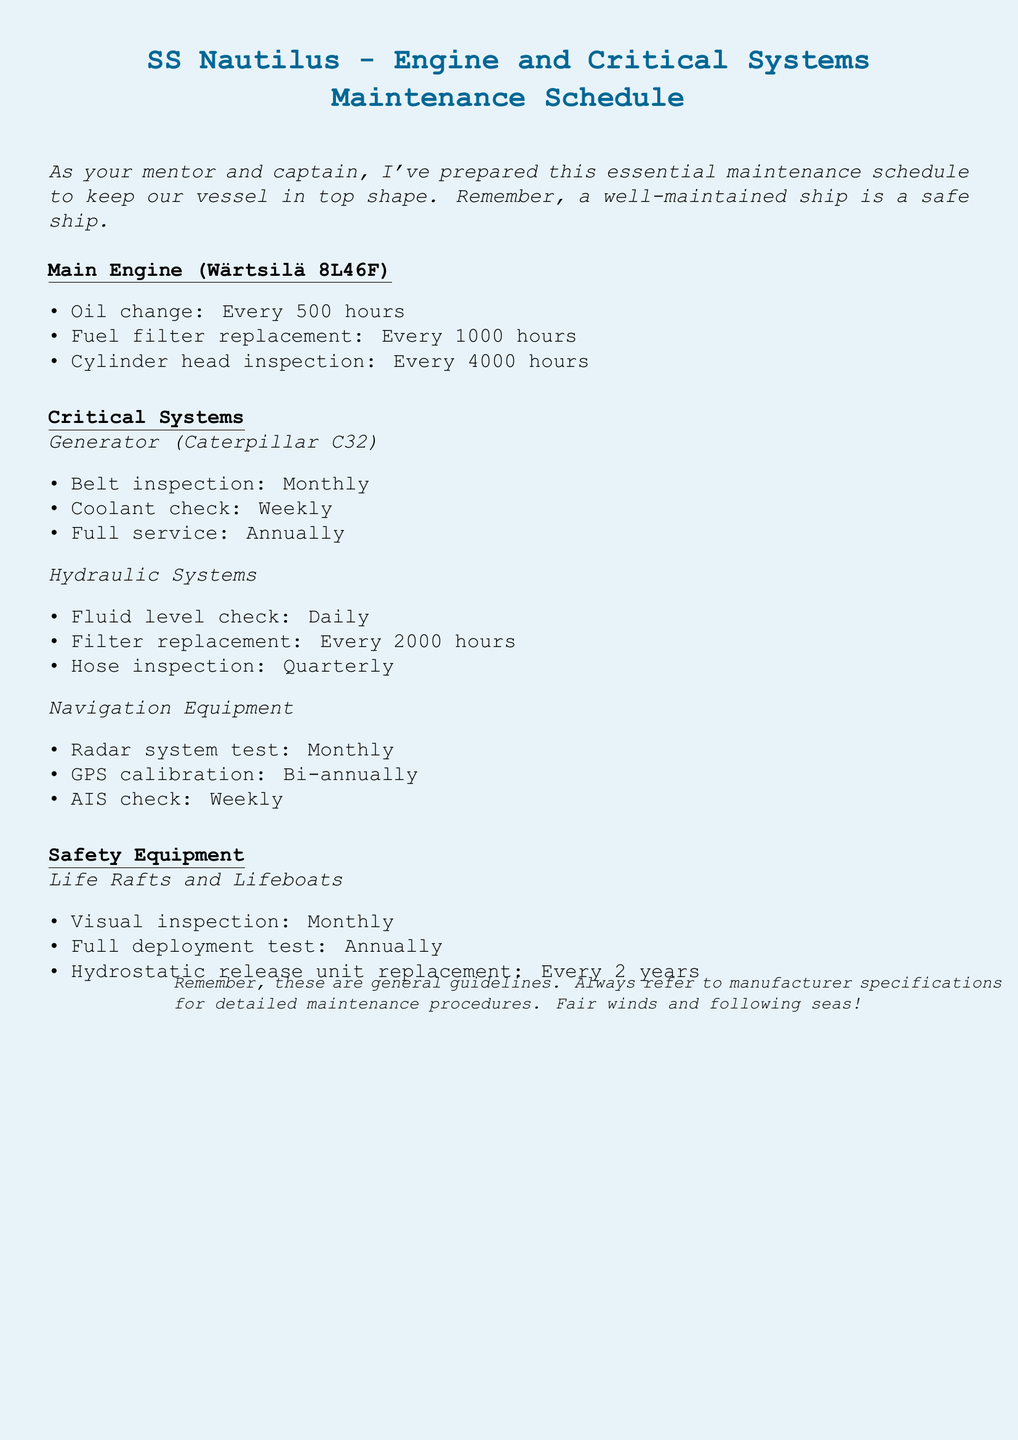what is the main engine model? The main engine model is specified at the beginning of the maintenance schedule under the main engine section.
Answer: Wärtsilä 8L46F how often should oil changes be performed? The frequency for oil changes is explicitly mentioned in the main engine maintenance list.
Answer: Every 500 hours what is the service interval for the fuel filter replacement? The document provides this information under the main engine maintenance section.
Answer: Every 1000 hours when should the coolant check for the generator be conducted? The frequency for the coolant check is stated in the generator maintenance section.
Answer: Weekly how often is a full deployment test for life rafts conducted? This is mentioned under the safety equipment section specific to life rafts and lifeboats.
Answer: Annually which system requires a fluid level check every day? This information is detailed in the hydraulic systems maintenance list.
Answer: Hydraulic Systems what is the recommended frequency for GPS calibration? The maintenance interval for GPS calibration is specified in the navigation equipment section.
Answer: Bi-annually how often should the hose inspection for hydraulic systems be performed? This frequency is mentioned in the hydraulic systems section of the document.
Answer: Quarterly what is the interval for hydrostatic release unit replacement? The document specifies this interval in the safety equipment section.
Answer: Every 2 years 